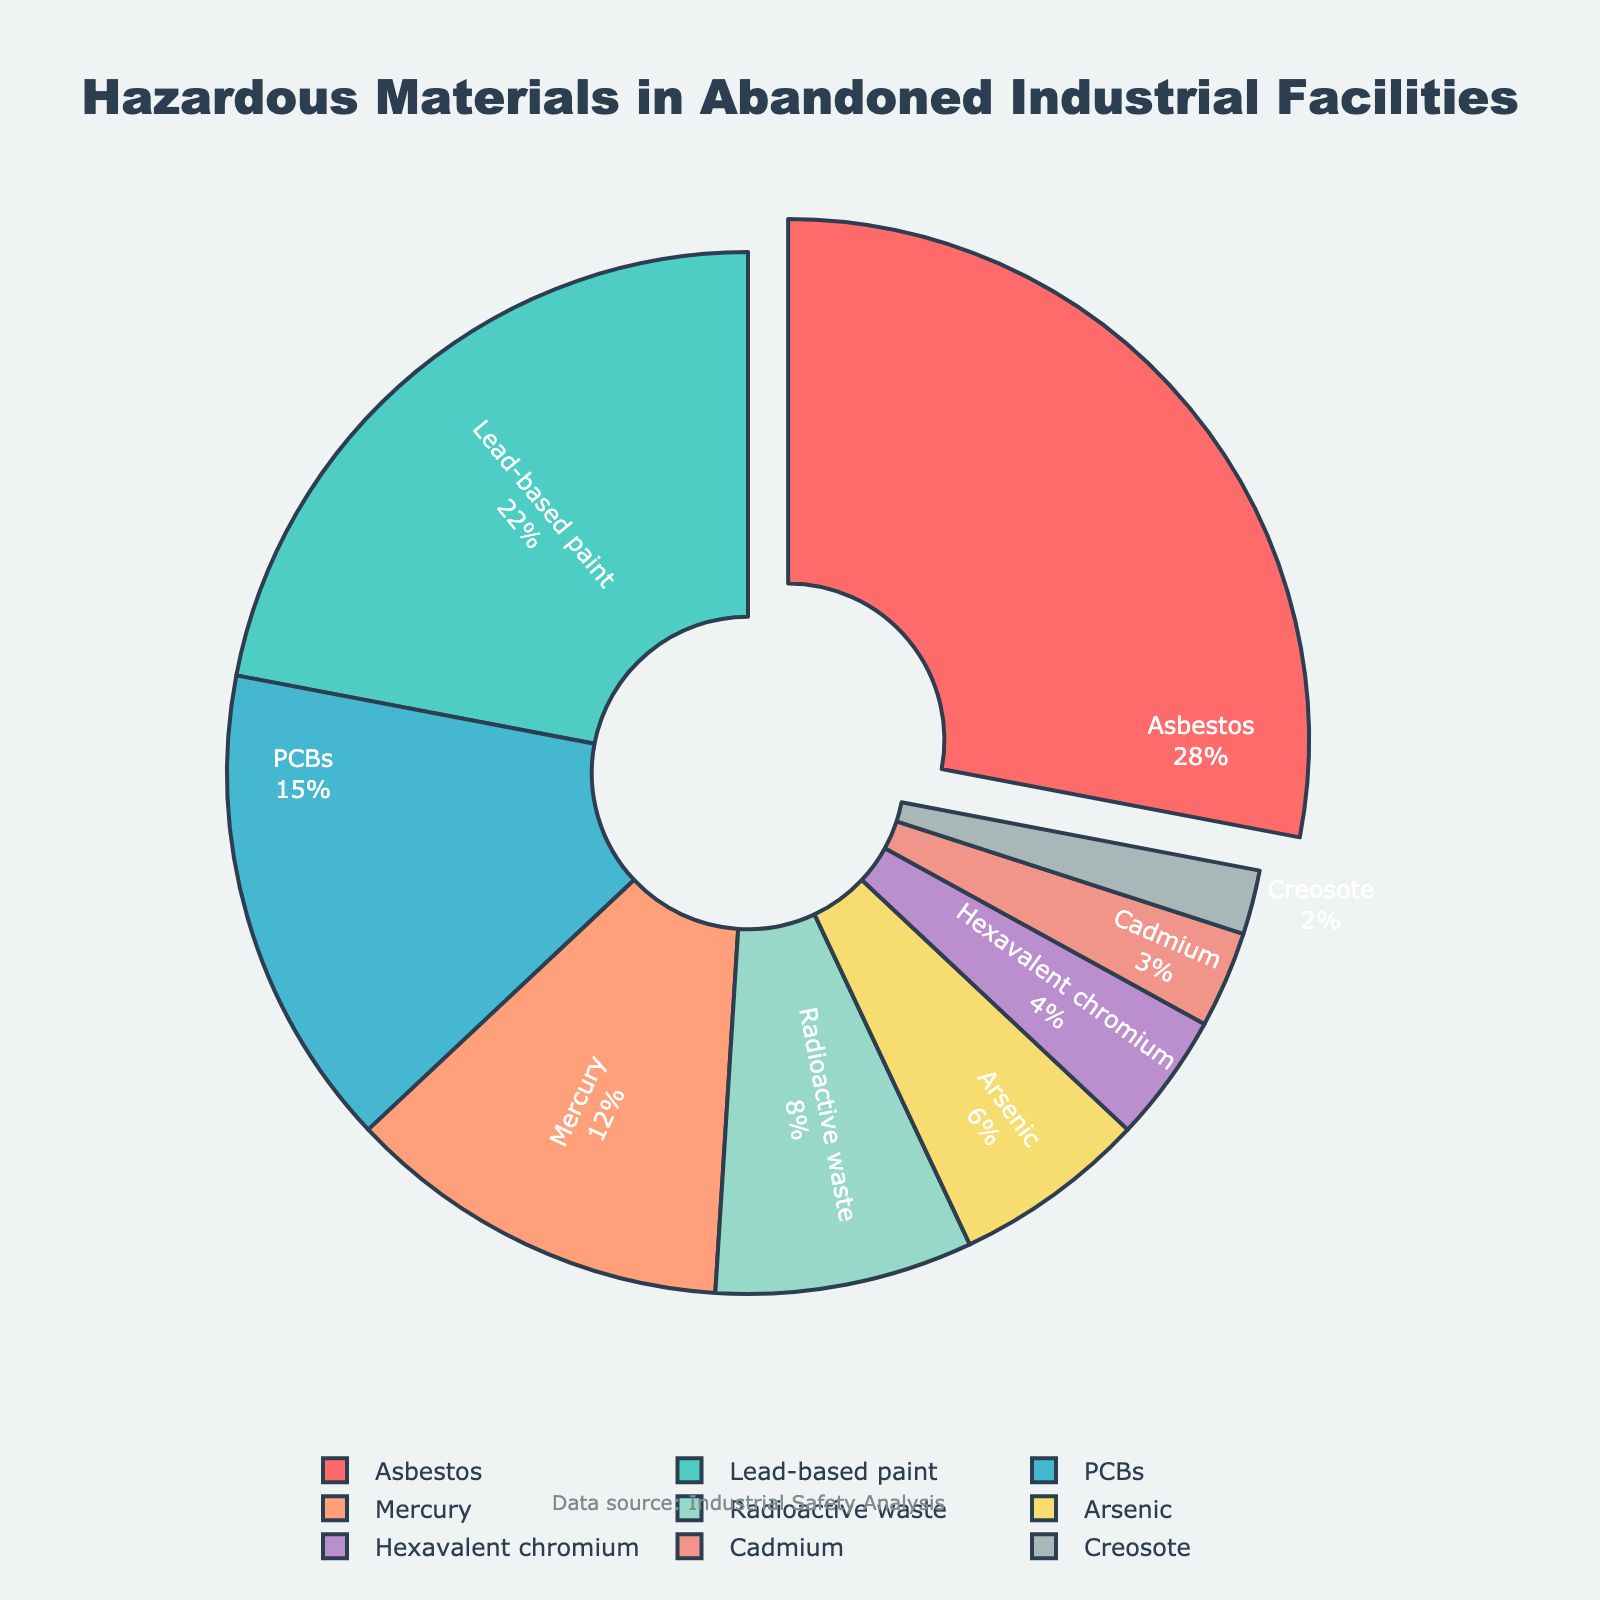Which hazardous material accounts for the largest percentage? The largest percentage section is pulled out from the pie chart. It represents 28% and is labeled as Asbestos.
Answer: Asbestos What is the combined percentage of Mercury and PCBs? Add the percentages of Mercury (12%) and PCBs (15%). 12 + 15 = 27
Answer: 27% How much more significant is the percentage of Lead-based paint compared to Creosote? Subtract the percentage of Creosote (2%) from Lead-based paint (22%). 22 - 2 = 20
Answer: 20% Which material is represented by the dark blue section in the pie chart? The dark blue section is positioned to the right of the pie and represents 12%. It is labeled as Mercury.
Answer: Mercury Is the percentage of Arsenic greater than that of Cadmium? Compare the percentage of Arsenic (6%) and Cadmium (3%). Since 6% is greater than 3%, Arsenic has a greater percentage.
Answer: Yes What is the total percentage of Radioactive waste, Hexavalent chromium, and Cadmium combined? Add the percentages of Radioactive waste (8%), Hexavalent chromium (4%), and Cadmium (3%). 8 + 4 + 3 = 15
Answer: 15% Which hazardous material has a smaller percentage, Creosote or Hexavalent chromium? Compare the percentages of Creosote (2%) and Hexavalent chromium (4%). Since 2% is smaller than 4%, Creosote has a smaller percentage.
Answer: Creosote What is the second-most prevalent hazardous material in the pie chart? The second-largest section represents 22% and is labeled as Lead-based paint.
Answer: Lead-based paint How does the percentage of PCBs compare to that of Mercury? Compare the percentages of PCBs (15%) and Mercury (12%). Since 15% is greater than 12%, PCBs have a higher percentage than Mercury.
Answer: PCBs What is the total percentage of all hazardous materials listed in the pie chart? Add the percentages of all materials: 28% (Asbestos) + 22% (Lead-based paint) + 15% (PCBs) + 12% (Mercury) + 8% (Radioactive waste) + 6% (Arsenic) + 4% (Hexavalent chromium) + 3% (Cadmium) + 2% (Creosote). 28 + 22 + 15 + 12 + 8 + 6 + 4 + 3 + 2 = 100
Answer: 100% 